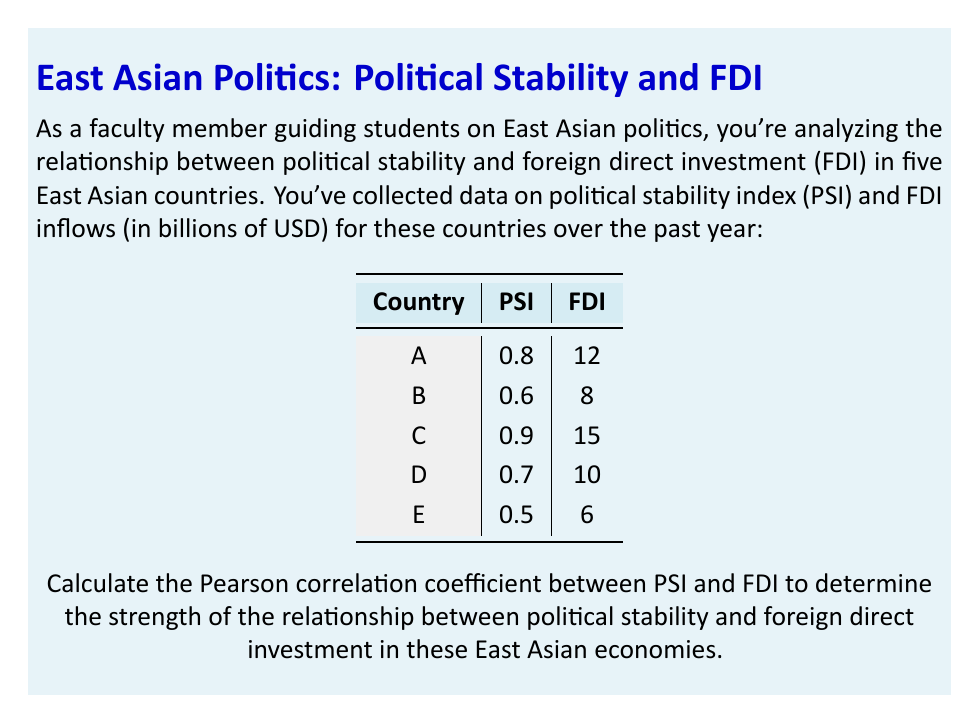Solve this math problem. To calculate the Pearson correlation coefficient, we'll use the formula:

$$ r = \frac{\sum_{i=1}^{n} (x_i - \bar{x})(y_i - \bar{y})}{\sqrt{\sum_{i=1}^{n} (x_i - \bar{x})^2 \sum_{i=1}^{n} (y_i - \bar{y})^2}} $$

Where:
$x_i$ = PSI values
$y_i$ = FDI values
$\bar{x}$ = mean of PSI values
$\bar{y}$ = mean of FDI values
$n$ = number of countries (5)

Step 1: Calculate means
$\bar{x} = \frac{0.8 + 0.6 + 0.9 + 0.7 + 0.5}{5} = 0.7$
$\bar{y} = \frac{12 + 8 + 15 + 10 + 6}{5} = 10.2$

Step 2: Calculate $(x_i - \bar{x})$ and $(y_i - \bar{y})$ for each country
Country | $(x_i - \bar{x})$ | $(y_i - \bar{y})$
--------|-------------------|-------------------
A       | 0.1               | 1.8
B       | -0.1              | -2.2
C       | 0.2               | 4.8
D       | 0                 | -0.2
E       | -0.2              | -4.2

Step 3: Calculate $(x_i - \bar{x})(y_i - \bar{y})$, $(x_i - \bar{x})^2$, and $(y_i - \bar{y})^2$
Country | $(x_i - \bar{x})(y_i - \bar{y})$ | $(x_i - \bar{x})^2$ | $(y_i - \bar{y})^2$
--------|----------------------------------|---------------------|---------------------
A       | 0.18                             | 0.01                | 3.24
B       | 0.22                             | 0.01                | 4.84
C       | 0.96                             | 0.04                | 23.04
D       | 0                                | 0                   | 0.04
E       | 0.84                             | 0.04                | 17.64

Step 4: Sum up the values
$\sum (x_i - \bar{x})(y_i - \bar{y}) = 2.2$
$\sum (x_i - \bar{x})^2 = 0.1$
$\sum (y_i - \bar{y})^2 = 48.8$

Step 5: Apply the formula
$$ r = \frac{2.2}{\sqrt{0.1 \times 48.8}} = \frac{2.2}{\sqrt{4.88}} = \frac{2.2}{2.209} \approx 0.9959 $$
Answer: 0.9959 